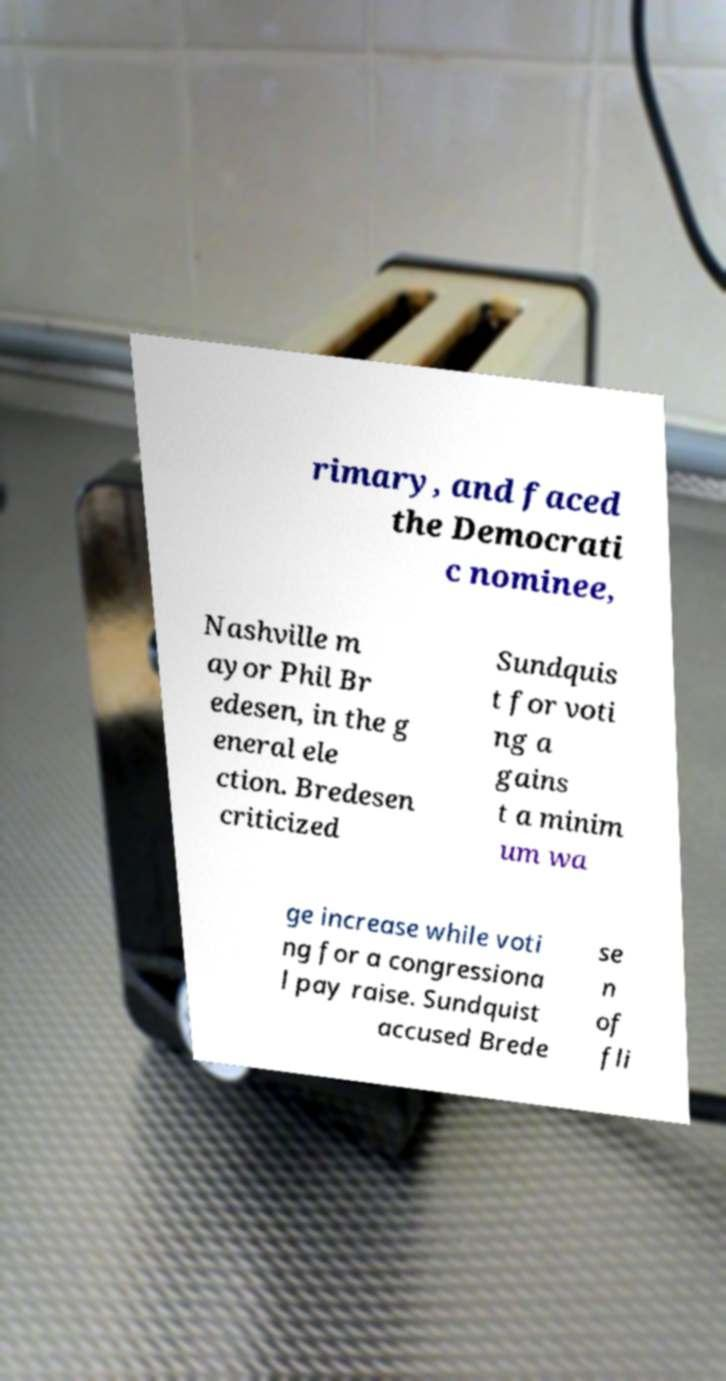Could you extract and type out the text from this image? rimary, and faced the Democrati c nominee, Nashville m ayor Phil Br edesen, in the g eneral ele ction. Bredesen criticized Sundquis t for voti ng a gains t a minim um wa ge increase while voti ng for a congressiona l pay raise. Sundquist accused Brede se n of fli 